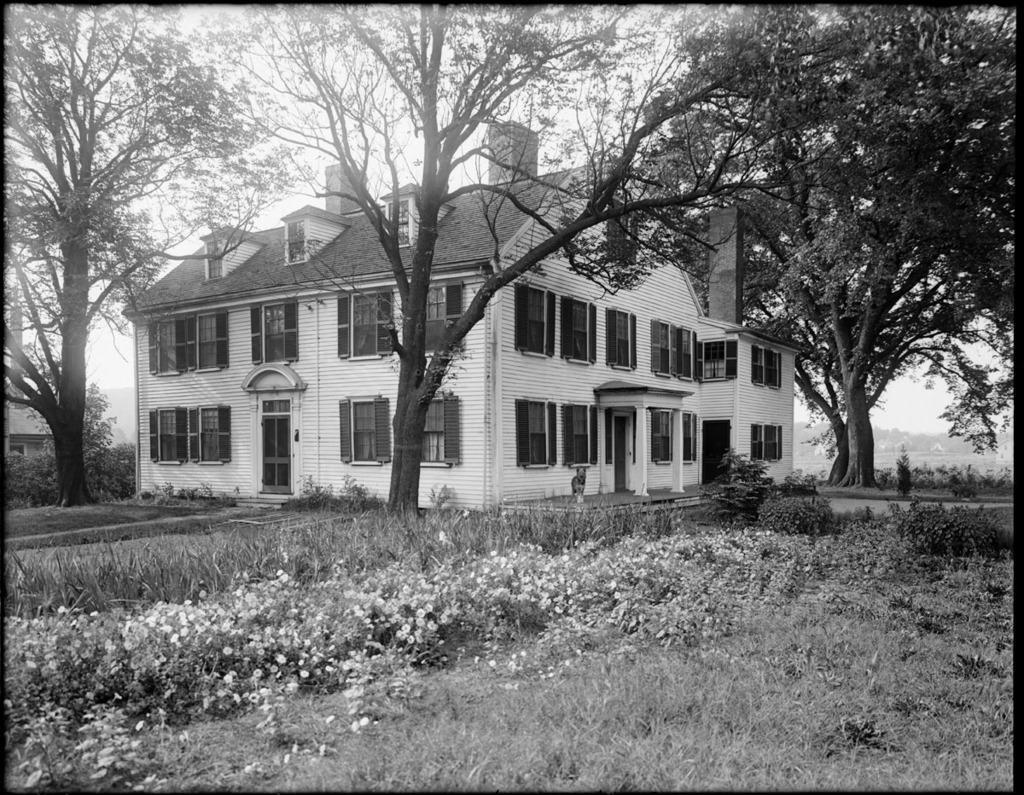Please provide a concise description of this image. In front of the image there are plants and flowers. At the bottom of the image there is grass on the surface. In the background of the image there are trees, buildings. At the top of the image there is sky. 